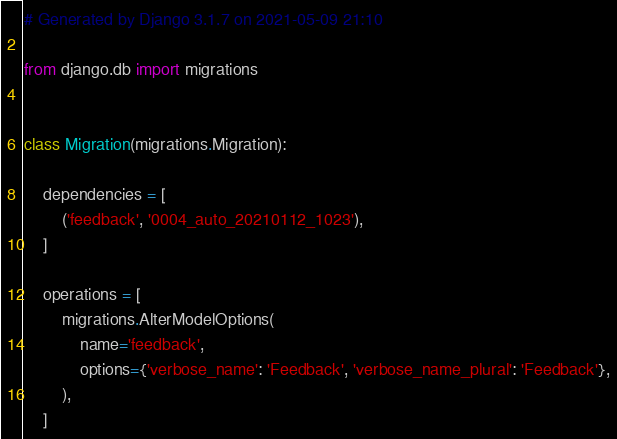Convert code to text. <code><loc_0><loc_0><loc_500><loc_500><_Python_># Generated by Django 3.1.7 on 2021-05-09 21:10

from django.db import migrations


class Migration(migrations.Migration):

    dependencies = [
        ('feedback', '0004_auto_20210112_1023'),
    ]

    operations = [
        migrations.AlterModelOptions(
            name='feedback',
            options={'verbose_name': 'Feedback', 'verbose_name_plural': 'Feedback'},
        ),
    ]
</code> 